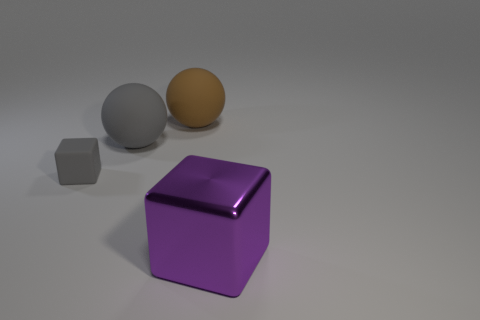Subtract 1 balls. How many balls are left? 1 Add 2 large red rubber things. How many objects exist? 6 Subtract all gray cylinders. How many green spheres are left? 0 Add 2 yellow cylinders. How many yellow cylinders exist? 2 Subtract 0 brown blocks. How many objects are left? 4 Subtract all gray cubes. Subtract all purple cylinders. How many cubes are left? 1 Subtract all spheres. Subtract all gray matte objects. How many objects are left? 0 Add 2 matte cubes. How many matte cubes are left? 3 